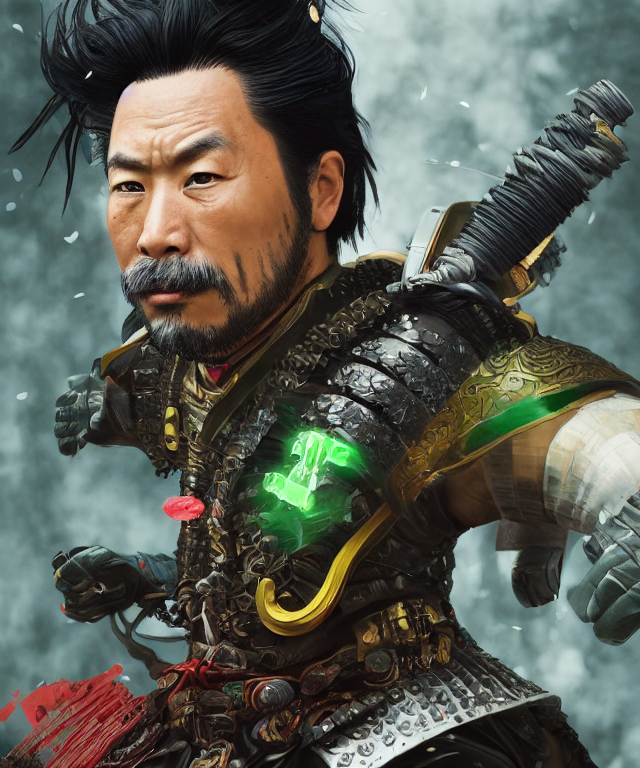What kind of atmosphere or mood is being conveyed by the image? The image portrays an intense and dramatic atmosphere. The character's stern expression, combined with the sharp, detailed armor and mystical glowing object, suggest an air of formidable strength and mystery. The snowy backdrop contributes to a sense of harshness and survival. 